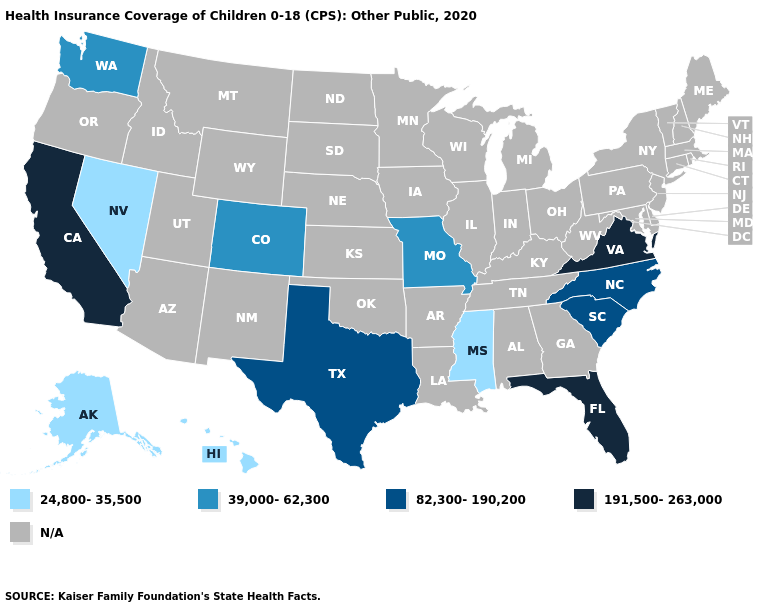Name the states that have a value in the range 24,800-35,500?
Give a very brief answer. Alaska, Hawaii, Mississippi, Nevada. How many symbols are there in the legend?
Short answer required. 5. Does the map have missing data?
Answer briefly. Yes. What is the lowest value in the West?
Quick response, please. 24,800-35,500. Does California have the highest value in the USA?
Give a very brief answer. Yes. Does Florida have the highest value in the USA?
Quick response, please. Yes. What is the value of Montana?
Concise answer only. N/A. Does North Carolina have the lowest value in the South?
Concise answer only. No. What is the lowest value in the USA?
Concise answer only. 24,800-35,500. Among the states that border Arizona , does Colorado have the highest value?
Quick response, please. No. What is the value of Utah?
Concise answer only. N/A. Which states have the highest value in the USA?
Give a very brief answer. California, Florida, Virginia. 